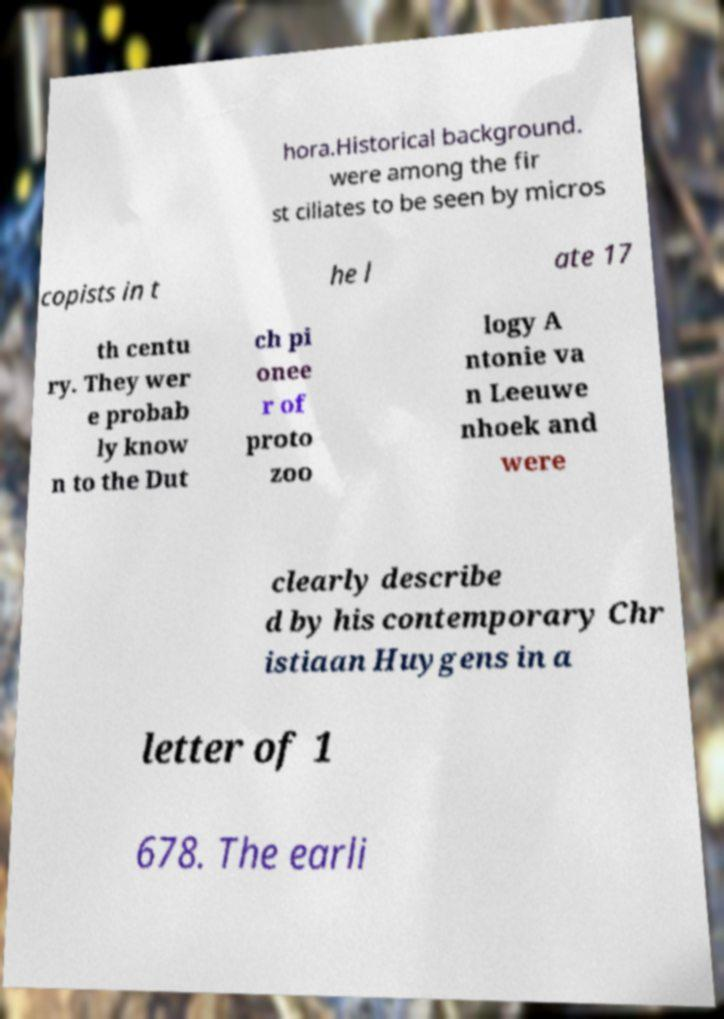Please identify and transcribe the text found in this image. hora.Historical background. were among the fir st ciliates to be seen by micros copists in t he l ate 17 th centu ry. They wer e probab ly know n to the Dut ch pi onee r of proto zoo logy A ntonie va n Leeuwe nhoek and were clearly describe d by his contemporary Chr istiaan Huygens in a letter of 1 678. The earli 